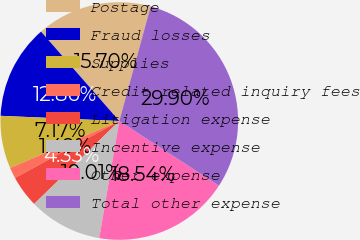<chart> <loc_0><loc_0><loc_500><loc_500><pie_chart><fcel>Postage<fcel>Fraud losses<fcel>Supplies<fcel>Credit related inquiry fees<fcel>Litigation expense<fcel>Incentive expense<fcel>Other expense<fcel>Total other expense<nl><fcel>15.7%<fcel>12.86%<fcel>7.17%<fcel>1.49%<fcel>4.33%<fcel>10.01%<fcel>18.54%<fcel>29.9%<nl></chart> 